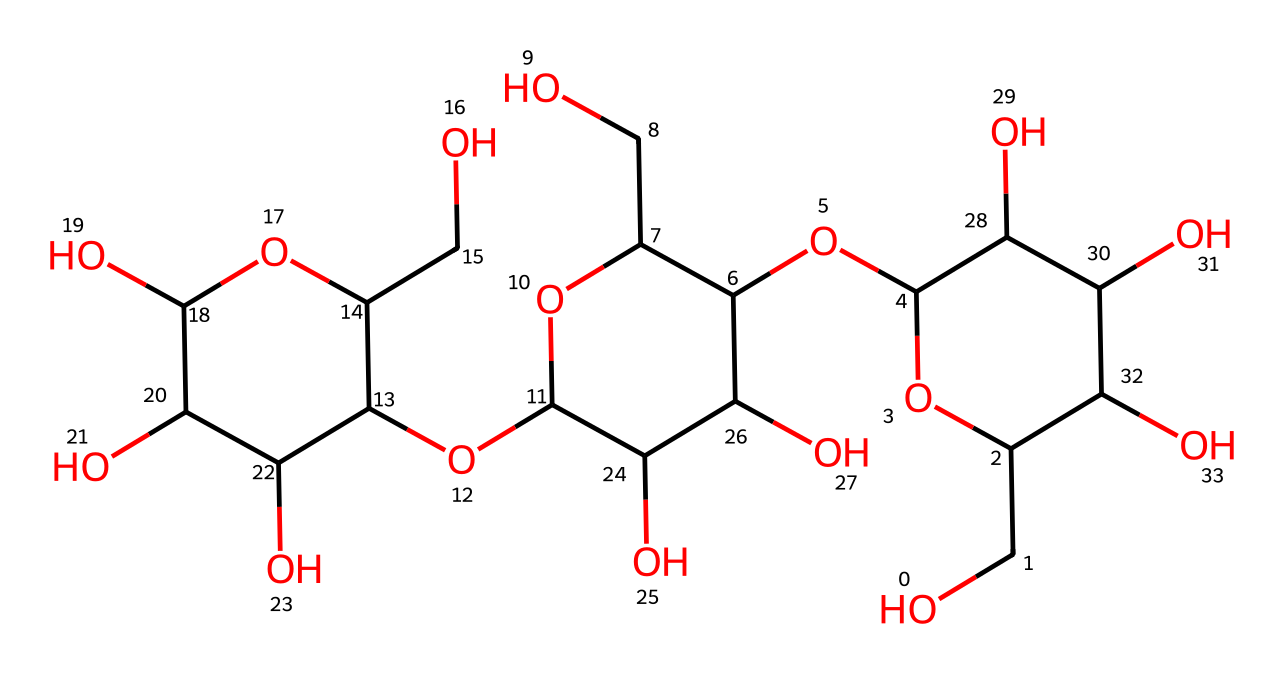What type of polymer is represented by this structure? The structure contains repeating units of glucose, which is characteristic of polysaccharides. Since cellulose is a polysaccharide made up of long chains of these glucose units, it falls under the category of polymers.
Answer: polysaccharide How many oxygen atoms are present in this structure? By examining the SMILES representation and counting the ‘O’ characters, there are 9 oxygen atoms in the structure.
Answer: 9 What is the primary functional group in this chemical? The structure contains multiple hydroxyl (-OH) groups that are characteristic of alcohols, making hydroxyl the primary functional group in cellulose.
Answer: hydroxyl What role does cellulose play in bamboo's physical properties? Cellulose provides strength and rigidity to bamboo, making it an essential component for its structural integrity. This is due to the long chains of glucose that aggregate and form fibers.
Answer: strength How many carbon atoms are there in this cellulose structure? The SMILES notation indicates a total of 6 carbon-containing structures in the repeating unit, replicated several times in the polymer chain. Counting these gives a total of 18 carbon atoms.
Answer: 18 What type of bonding is primarily found in cellulose's structure? The structure features glycosidic linkages between glucose units, which are a type of covalent bonding essential in forming the long chains characteristic of cellulose.
Answer: covalent Which type of bonding contributes to the rigidity of bamboo? The extensive hydrogen bonding between hydroxyl groups in the cellulose chains contributes significantly to the rigidity and strength of bamboo fibers.
Answer: hydrogen bonding 